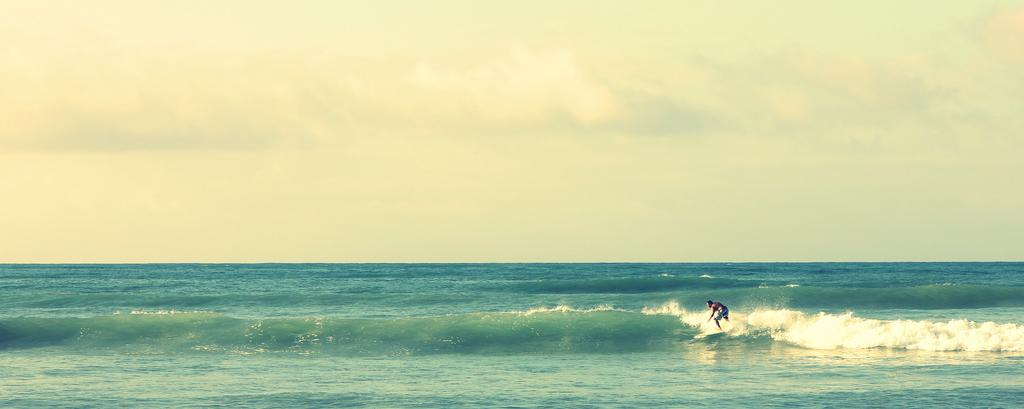Who or what is the main subject in the image? There is a person in the image. What is the person doing in the image? The person is standing on a surfing board. Where is the surfing board located? The surfing board is on a river. What can be seen in the background of the image? There is a sky visible in the background of the image. Can you see any islands in the image? There are no islands visible in the image; it features a person standing on a surfing board on a river. What type of knee protection is the person wearing in the image? There is no knee protection visible in the image, as the person is wearing regular clothing while surfing. 